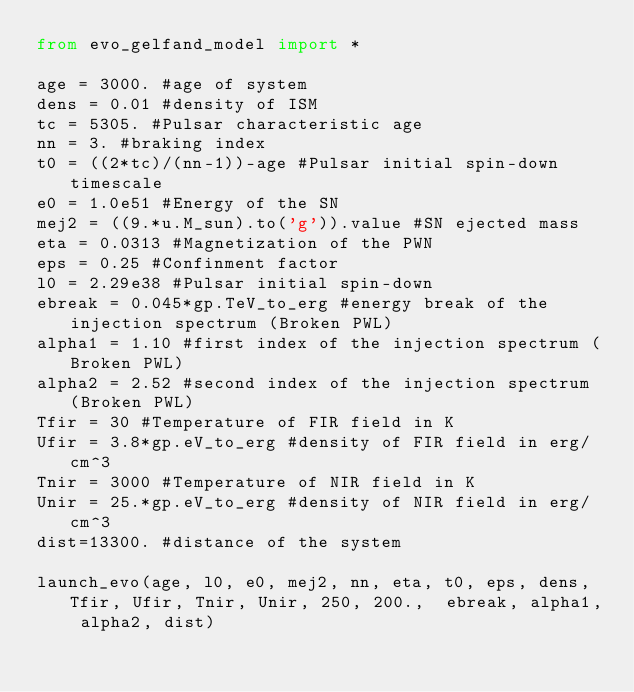Convert code to text. <code><loc_0><loc_0><loc_500><loc_500><_Python_>from evo_gelfand_model import *

age = 3000. #age of system
dens = 0.01 #density of ISM
tc = 5305. #Pulsar characteristic age
nn = 3. #braking index
t0 = ((2*tc)/(nn-1))-age #Pulsar initial spin-down timescale
e0 = 1.0e51 #Energy of the SN
mej2 = ((9.*u.M_sun).to('g')).value #SN ejected mass
eta = 0.0313 #Magnetization of the PWN
eps = 0.25 #Confinment factor
l0 = 2.29e38 #Pulsar initial spin-down
ebreak = 0.045*gp.TeV_to_erg #energy break of the injection spectrum (Broken PWL)
alpha1 = 1.10 #first index of the injection spectrum (Broken PWL)
alpha2 = 2.52 #second index of the injection spectrum (Broken PWL)
Tfir = 30 #Temperature of FIR field in K
Ufir = 3.8*gp.eV_to_erg #density of FIR field in erg/cm^3
Tnir = 3000 #Temperature of NIR field in K
Unir = 25.*gp.eV_to_erg #density of NIR field in erg/cm^3
dist=13300. #distance of the system

launch_evo(age, l0, e0, mej2, nn, eta, t0, eps, dens, Tfir, Ufir, Tnir, Unir, 250, 200.,  ebreak, alpha1, alpha2, dist)
</code> 